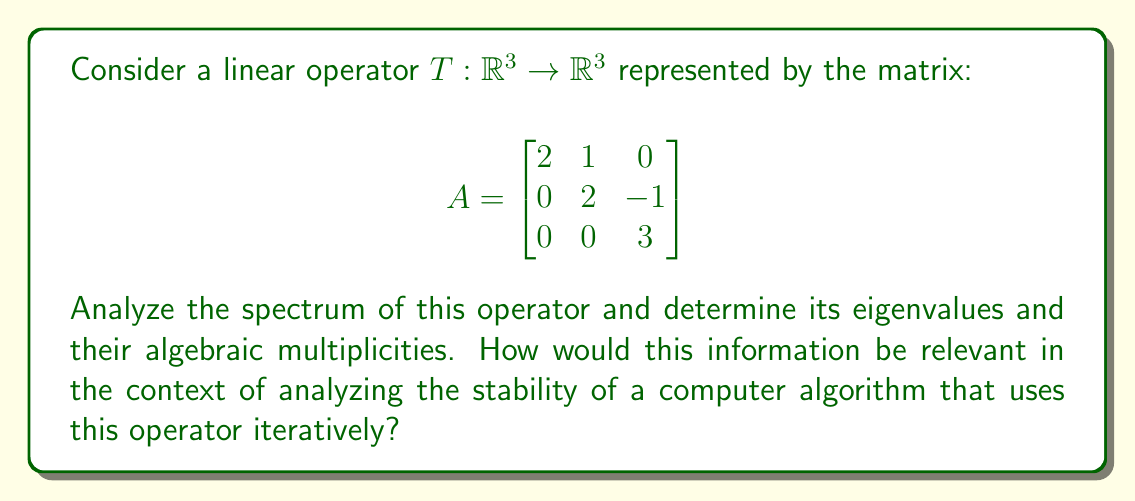Teach me how to tackle this problem. To analyze the spectrum of the linear operator T, we need to follow these steps:

1) Find the characteristic polynomial:
   $p(\lambda) = det(A - \lambda I)$
   
   $$det\begin{bmatrix}
   2-\lambda & 1 & 0 \\
   0 & 2-\lambda & -1 \\
   0 & 0 & 3-\lambda
   \end{bmatrix}$$

2) Expand the determinant:
   $p(\lambda) = (2-\lambda)(2-\lambda)(3-\lambda)$

3) Factor the characteristic polynomial:
   $p(\lambda) = (2-\lambda)^2(3-\lambda)$

4) Find the roots of $p(\lambda)$:
   $\lambda_1 = 2$ (with algebraic multiplicity 2)
   $\lambda_2 = 3$ (with algebraic multiplicity 1)

5) The spectrum of T is the set of eigenvalues:
   $\sigma(T) = \{2, 3\}$

In the context of analyzing the stability of a computer algorithm that uses this operator iteratively:

- The spectral radius (largest absolute eigenvalue) is 3, which indicates the long-term behavior of the algorithm.
- If the algorithm involves powers of this matrix, $A^n$, the eigenvalue 3 will dominate as n increases.
- The presence of a repeated eigenvalue (2) might lead to polynomial growth in certain directions, which could affect numerical stability.
- Understanding this spectrum allows for predicting and controlling the convergence or divergence of iterative methods involving this operator.
Answer: Spectrum: $\sigma(T) = \{2, 3\}$; Eigenvalues: $\lambda_1 = 2$ (algebraic multiplicity 2), $\lambda_2 = 3$ (algebraic multiplicity 1) 